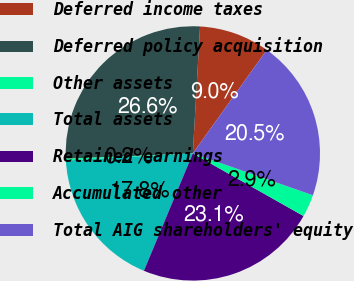<chart> <loc_0><loc_0><loc_500><loc_500><pie_chart><fcel>Deferred income taxes<fcel>Deferred policy acquisition<fcel>Other assets<fcel>Total assets<fcel>Retained earnings<fcel>Accumulated other<fcel>Total AIG shareholders' equity<nl><fcel>8.97%<fcel>26.58%<fcel>0.22%<fcel>17.82%<fcel>23.09%<fcel>2.86%<fcel>20.46%<nl></chart> 